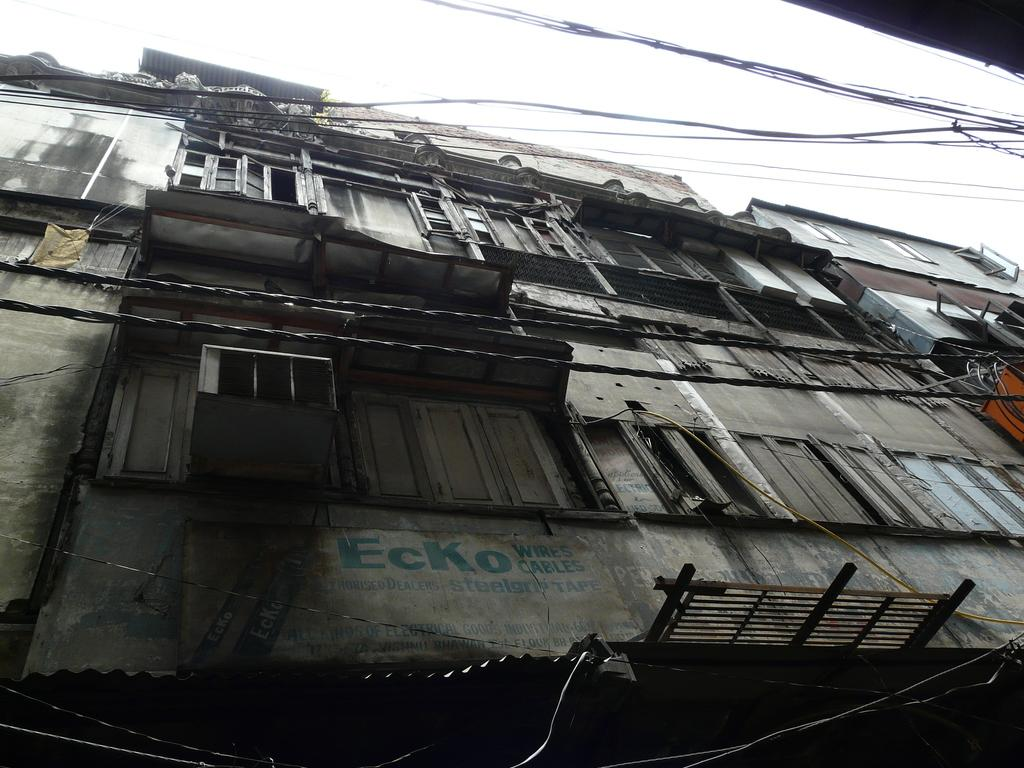What type of structure is visible in the image? There is a building in the image. What feature can be seen on the building? There are windows in the building. What other structure is present in the image? There is a shed in the image. What is used to identify the location or name of the building? There is a name board in the image. What is visible in the background of the image? The sky is visible in the image. What type of infrastructure is present in the image? Electric cables are present in the image. Can you see any yaks grazing in the image? There are no yaks present in the image. What type of straw is used to decorate the shed in the image? There is no straw visible in the image, and the shed is not decorated. 